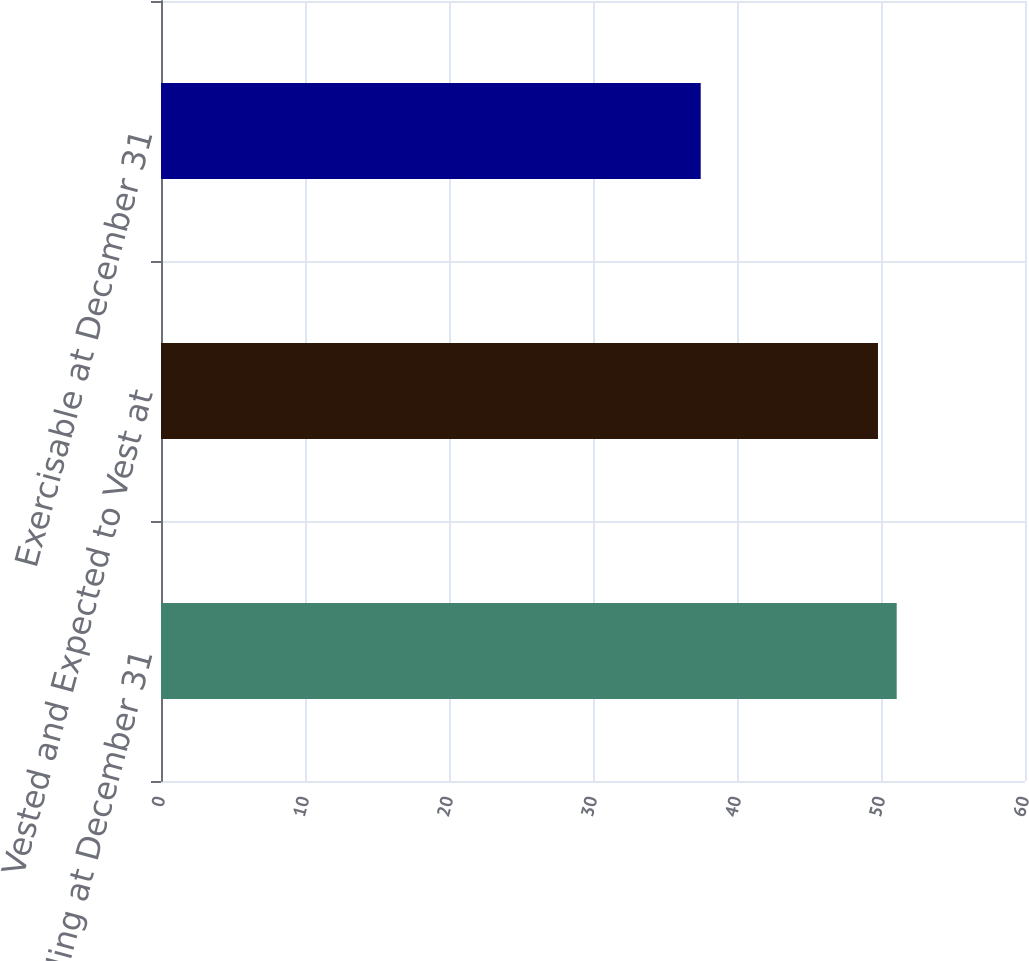<chart> <loc_0><loc_0><loc_500><loc_500><bar_chart><fcel>Outstanding at December 31<fcel>Vested and Expected to Vest at<fcel>Exercisable at December 31<nl><fcel>51.09<fcel>49.79<fcel>37.48<nl></chart> 